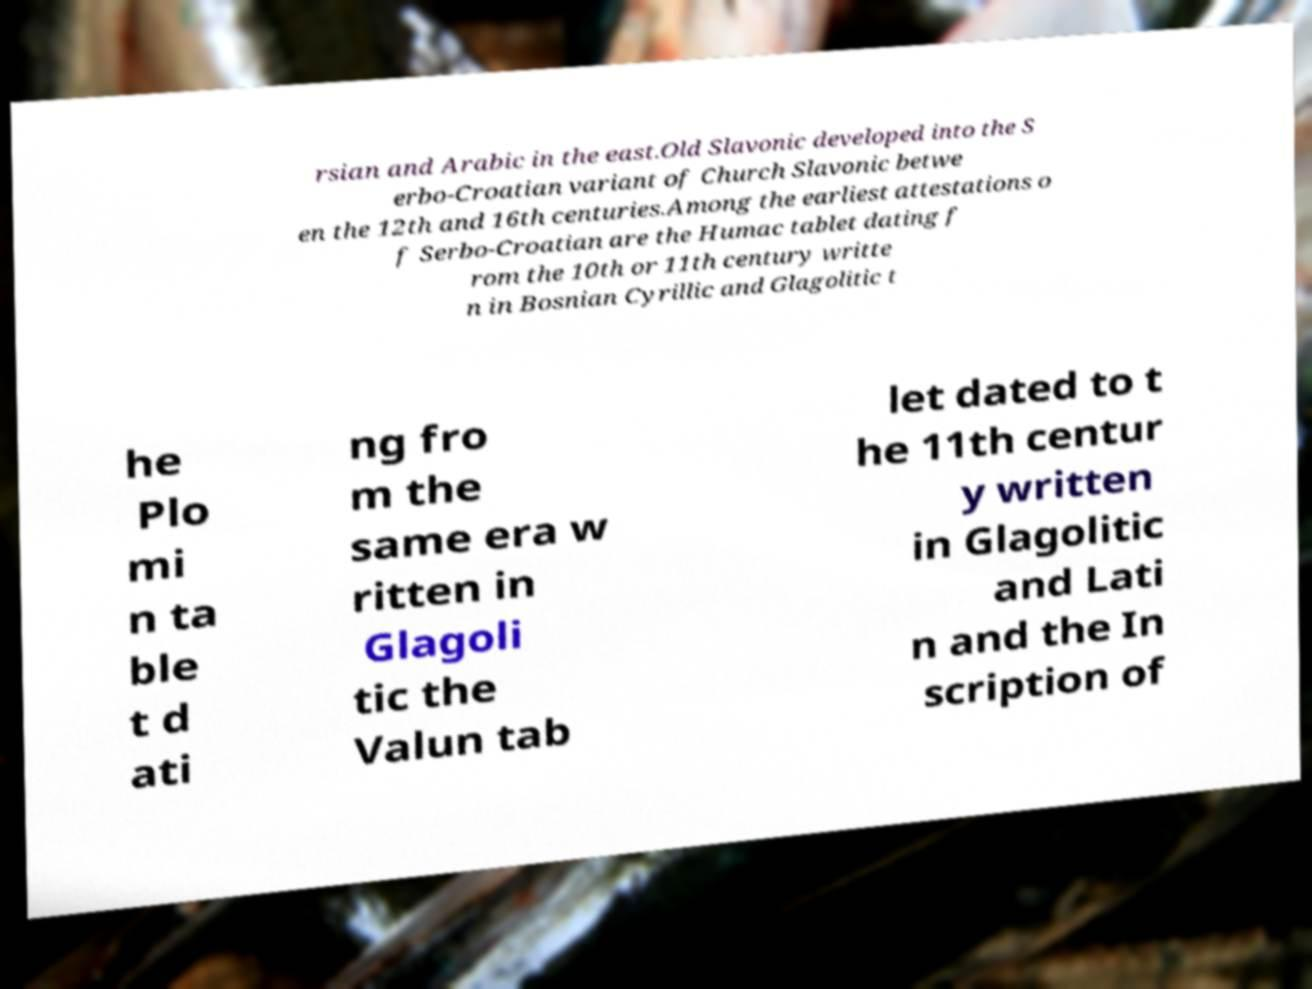Could you assist in decoding the text presented in this image and type it out clearly? rsian and Arabic in the east.Old Slavonic developed into the S erbo-Croatian variant of Church Slavonic betwe en the 12th and 16th centuries.Among the earliest attestations o f Serbo-Croatian are the Humac tablet dating f rom the 10th or 11th century writte n in Bosnian Cyrillic and Glagolitic t he Plo mi n ta ble t d ati ng fro m the same era w ritten in Glagoli tic the Valun tab let dated to t he 11th centur y written in Glagolitic and Lati n and the In scription of 